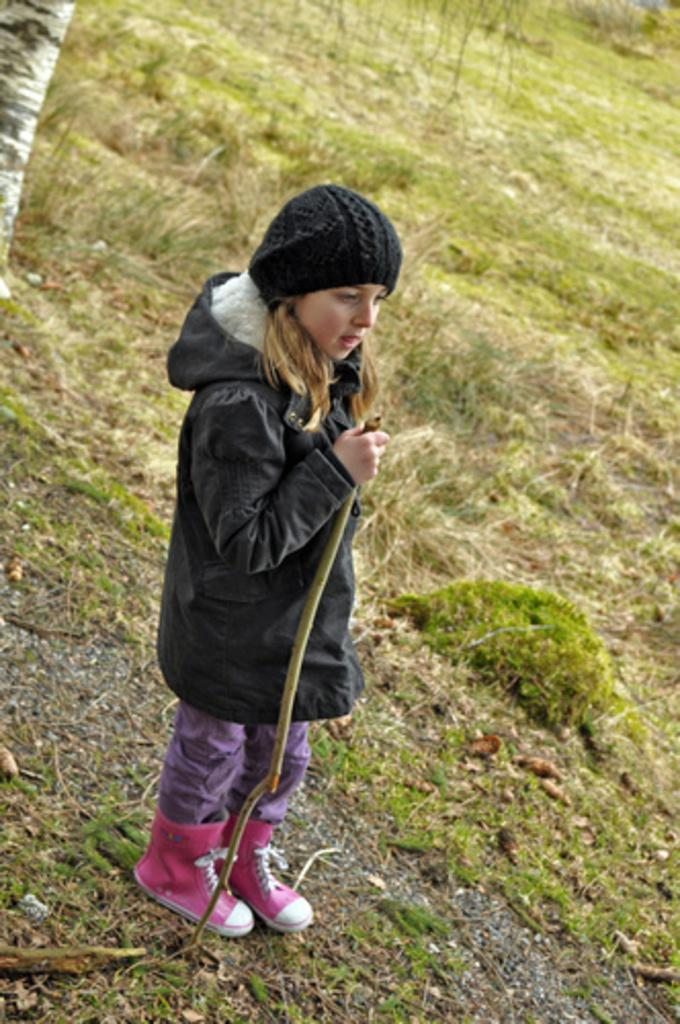Who is the main subject in the image? There is a girl in the image. What is the girl wearing on her head? The girl is wearing a cap. What type of clothing is the girl wearing on her upper body? The girl is wearing a jacket. What type of footwear is the girl wearing? The girl is wearing shoes. What is the girl holding in her hand? The girl is holding a stick with her hand. What is the girl standing on in the image? The girl is standing on the ground. What type of vegetation can be seen in the background of the image? There is grass in the background of the image. What type of oatmeal is the girl eating in the image? There is no oatmeal present in the image; the girl is holding a stick. What cloud formation can be seen in the background of the image? There are no clouds visible in the image; only grass can be seen in the background. 